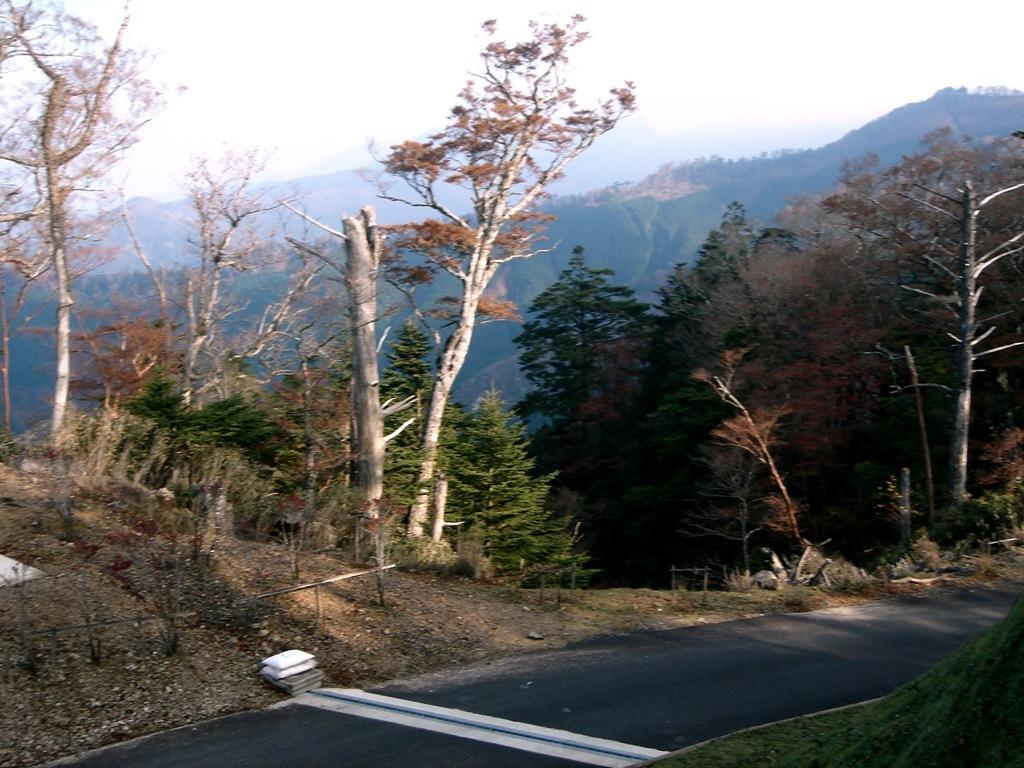What is located at the bottom of the picture? There is a road at the bottom of the picture. What can be seen alongside the road? There are trees on the side of the road. What is visible in the background of the image? There are hills visible in the background of the image. What type of request is being made by the society in the image? There is no indication of a society or any requests being made in the image. 